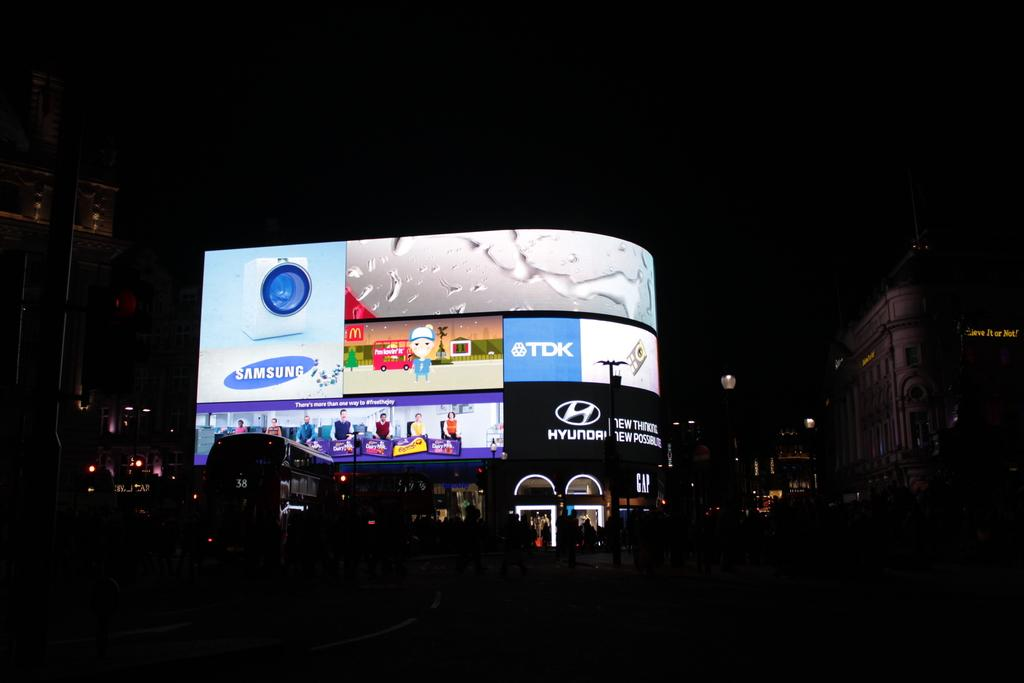<image>
Relay a brief, clear account of the picture shown. the word Samsung is on the screen above the street 